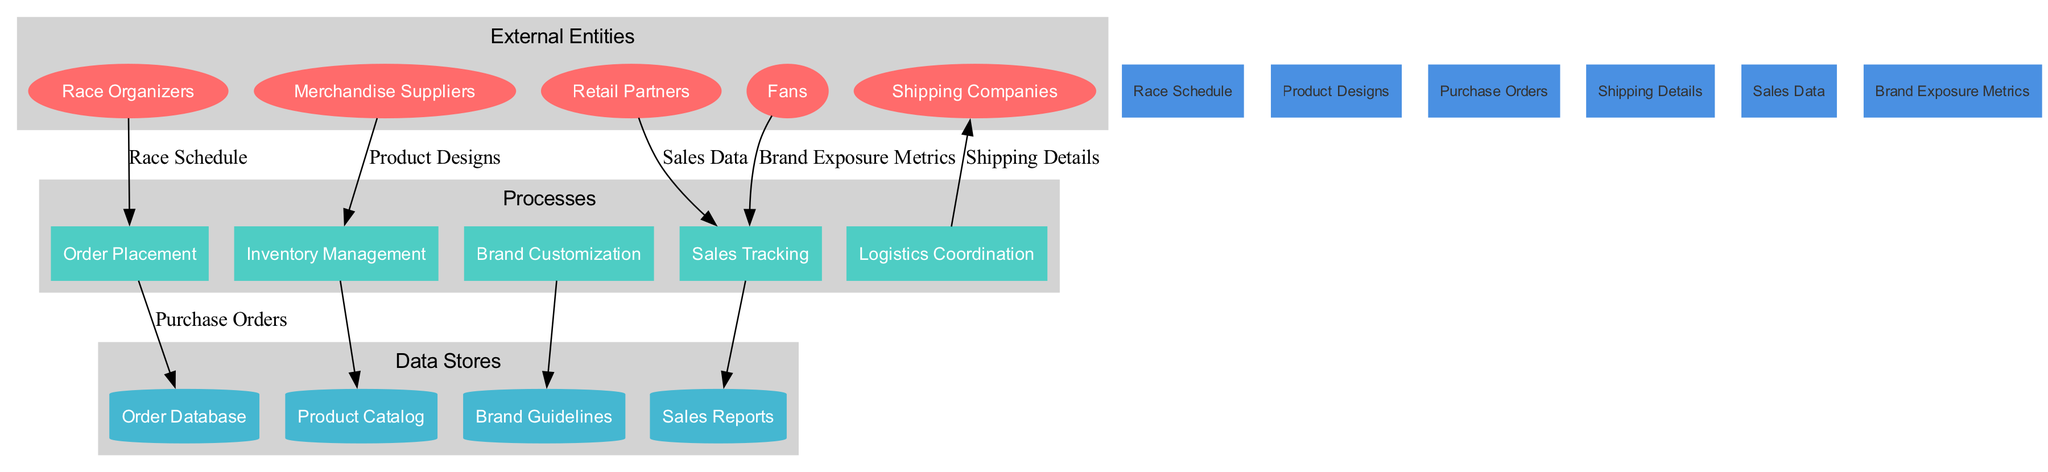What are the external entities in the diagram? The external entities are clearly labeled in a distinct section of the diagram. They include "Race Organizers", "Merchandise Suppliers", "Shipping Companies", "Retail Partners", and "Fans".
Answer: Race Organizers, Merchandise Suppliers, Shipping Companies, Retail Partners, Fans How many processes are present in the diagram? By looking at the section labeled "Processes", we can count a total of five distinct processes: "Order Placement", "Inventory Management", "Brand Customization", "Logistics Coordination", and "Sales Tracking".
Answer: 5 What data flows into the "Sales Tracking" process? The "Sales Tracking" process has incoming data flows from two entities: "Retail Partners" (providing "Sales Data") and "Fans" (providing "Brand Exposure Metrics"). Thus, there are two distinct data flows into this process.
Answer: Sales Data, Brand Exposure Metrics Which external entity sends "Shipping Details"? The arrow depicting data flow shows that "Shipping Companies" are connected to the "Logistics Coordination" process, and they send "Shipping Details" as indicated by the label on the connecting line.
Answer: Shipping Companies What is the purpose of the "Brand Customization" process? The "Brand Customization" process connects to the "Brand Guidelines" data store, indicating that the purpose is to align merchandise with specific branding instructions, involving changes or adaptations based on those guidelines.
Answer: Align merchandise with branding instructions What type of data is stored in the "Order Database"? The "Order Database" is associated with the "Purchase Orders" data flow, which suggests it stores information related to the orders placed by fans or retailers, including details about quantities, items, and purchasing entities.
Answer: Purchase Orders How do "Merchandise Suppliers" influence "Inventory Management"? The "Merchandise Suppliers" provide data flows labeled "Product Designs" into the "Inventory Management" process. This indicates that suppliers impact inventory by supplying information on the products available for management.
Answer: Product Designs Which process is directly connected to the "Product Catalog"? The "Product Catalog" is connected to the "Inventory Management" process, as depicted by a direct edge in the diagram, indicating that inventory management involves maintaining and updating the product catalog.
Answer: Inventory Management What metrics are associated with "Brand Exposure"? The "Fans" are connected to the "Sales Tracking" process with the data flow labeled "Brand Exposure Metrics", suggesting these metrics relate to the impact of merchandise sales on brand visibility and recognition.
Answer: Brand Exposure Metrics 